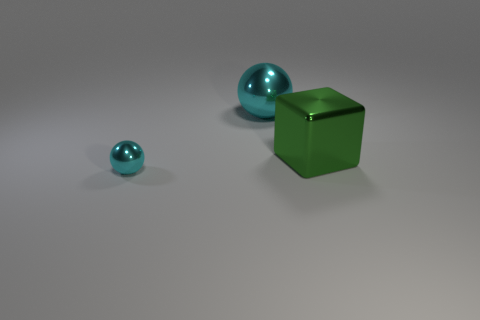Is the tiny cyan thing that is in front of the big cyan shiny thing made of the same material as the large cyan object?
Provide a succinct answer. Yes. What material is the big cyan thing that is the same shape as the tiny cyan metal object?
Offer a terse response. Metal. There is another object that is the same color as the tiny metallic object; what material is it?
Ensure brevity in your answer.  Metal. Is the number of large cyan cylinders less than the number of big green metallic cubes?
Make the answer very short. Yes. Does the sphere that is in front of the big cyan metal object have the same color as the large metal sphere?
Offer a very short reply. Yes. There is a big thing that is made of the same material as the large green cube; what is its color?
Make the answer very short. Cyan. What is the material of the tiny cyan ball?
Keep it short and to the point. Metal. There is a cyan thing that is the same size as the green shiny object; what material is it?
Provide a succinct answer. Metal. Is there a metal cube that has the same size as the green thing?
Offer a terse response. No. Are there an equal number of tiny metal objects that are behind the green shiny block and cubes in front of the big shiny sphere?
Offer a terse response. No. 